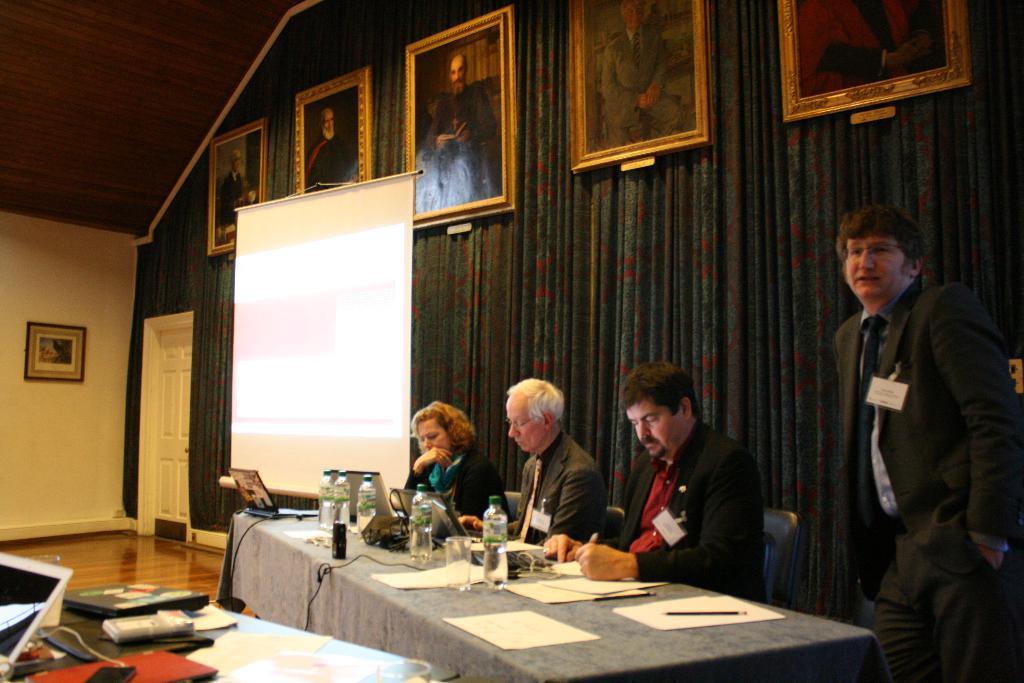Please provide a concise description of this image. In the center of the image there is a table and we can see bottles, laptops, papers, glasses and lens placed on the table. There are three people sitting. On the right there is a man standing. At the bottom we can see things placed on the table. In the background there is a wall, door and wall frames placed on the wall. We can see a board. 